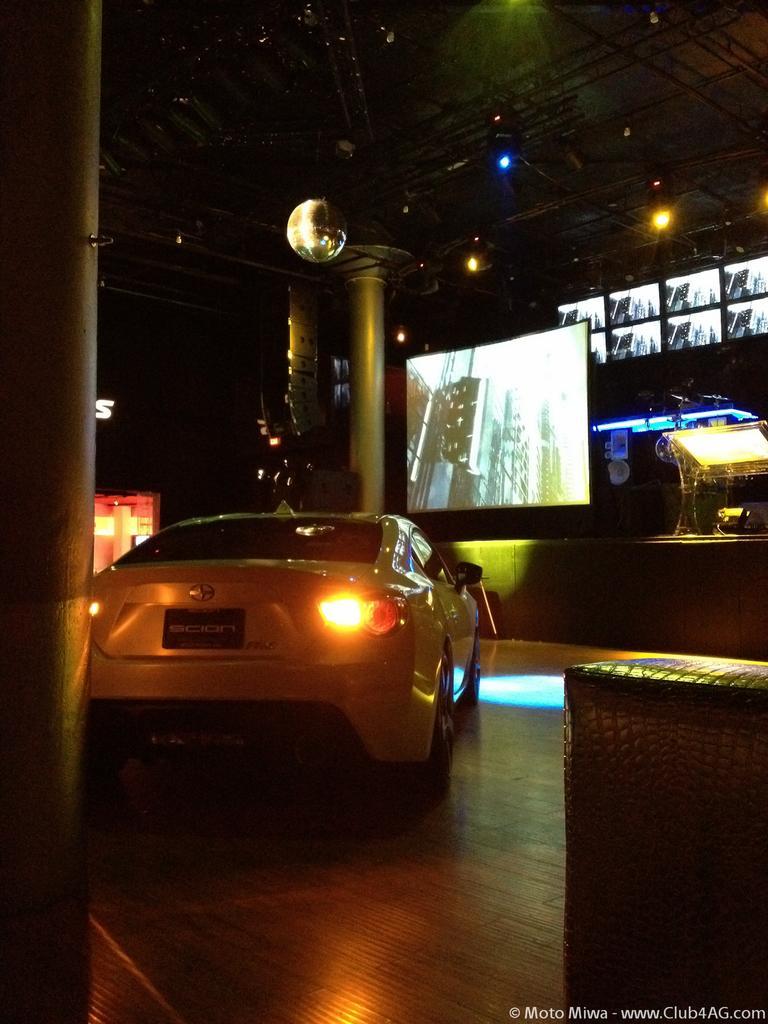Can you describe this image briefly? In this image there is a car, there is a wooden floor, there are pillars, there is a pillar towards the left of the image, there is text towards the bottom of the image, there is a wall, there is an object on the wall, there is a screen, there is a podium on the stage, there is the roof towards the top of the image, there are lights. 